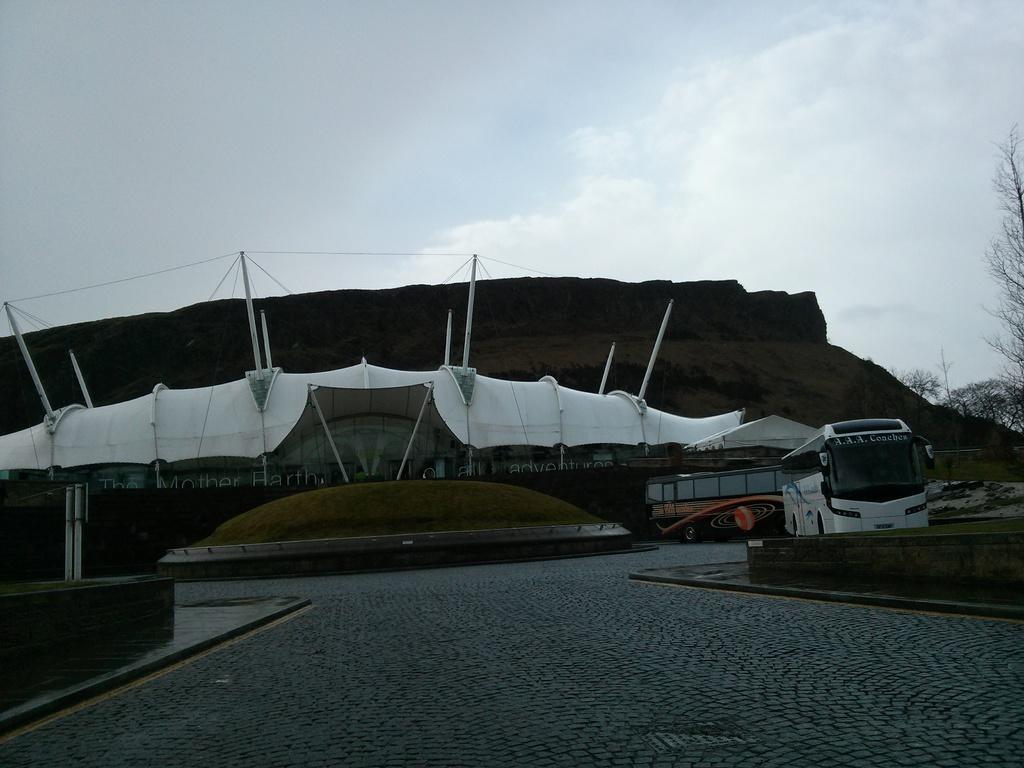Please provide a concise description of this image. In this image there are few buses on the road. There is grassland. Background there is building. Right side there are few trees. Top of the image there is sky. Bottom of image there is cobble stone path. Left side there is a wall. 